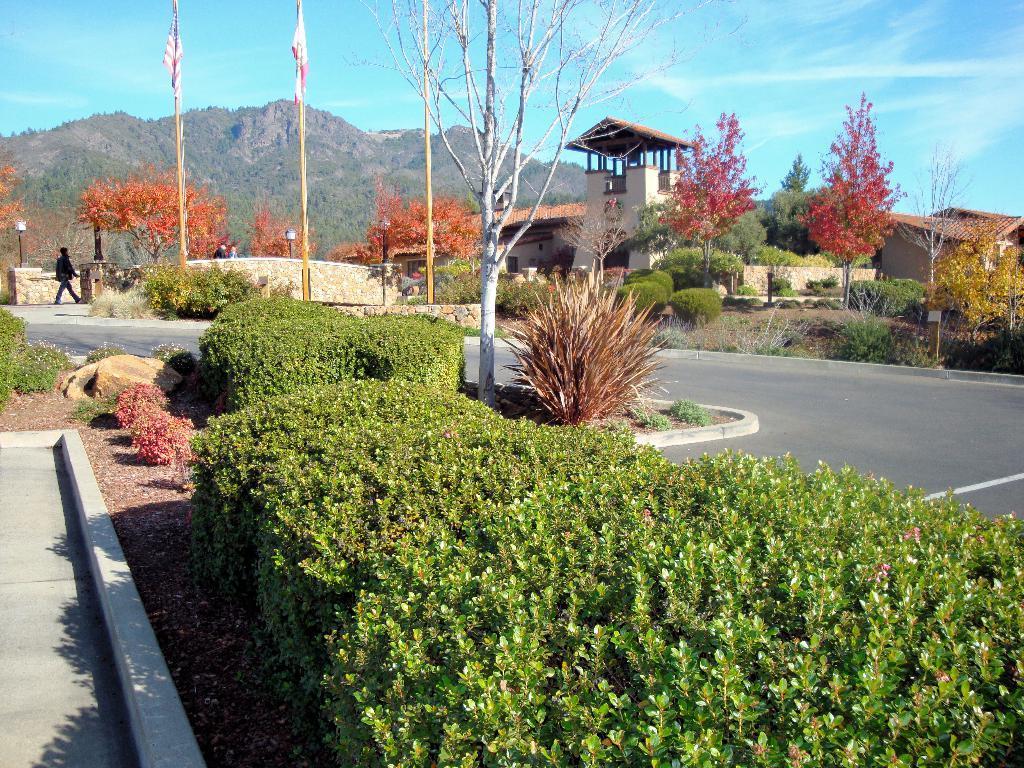Can you describe this image briefly? In this picture I can see number of plants and trees in front and I can see the path on the right side of this image. In the middle of this picture I can see few buildings and 2 poles, on which I can see 2 flags. In the background I can see the mountains and the clear sky. I can also see a person on the left side of this image. 